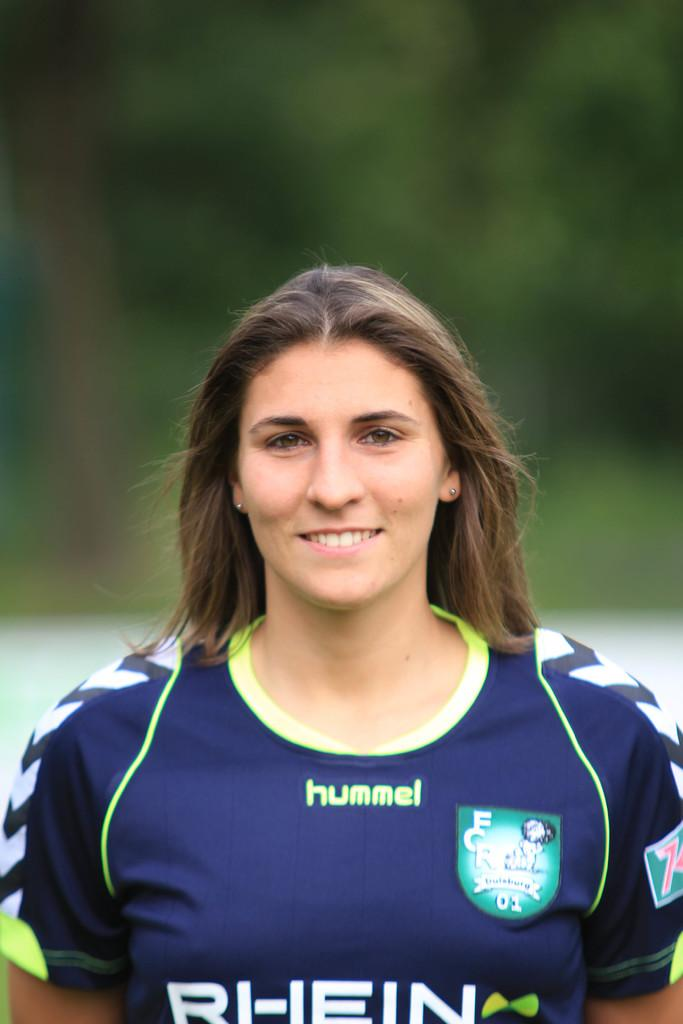<image>
Provide a brief description of the given image. a lady that has the word hummel on her shirt 